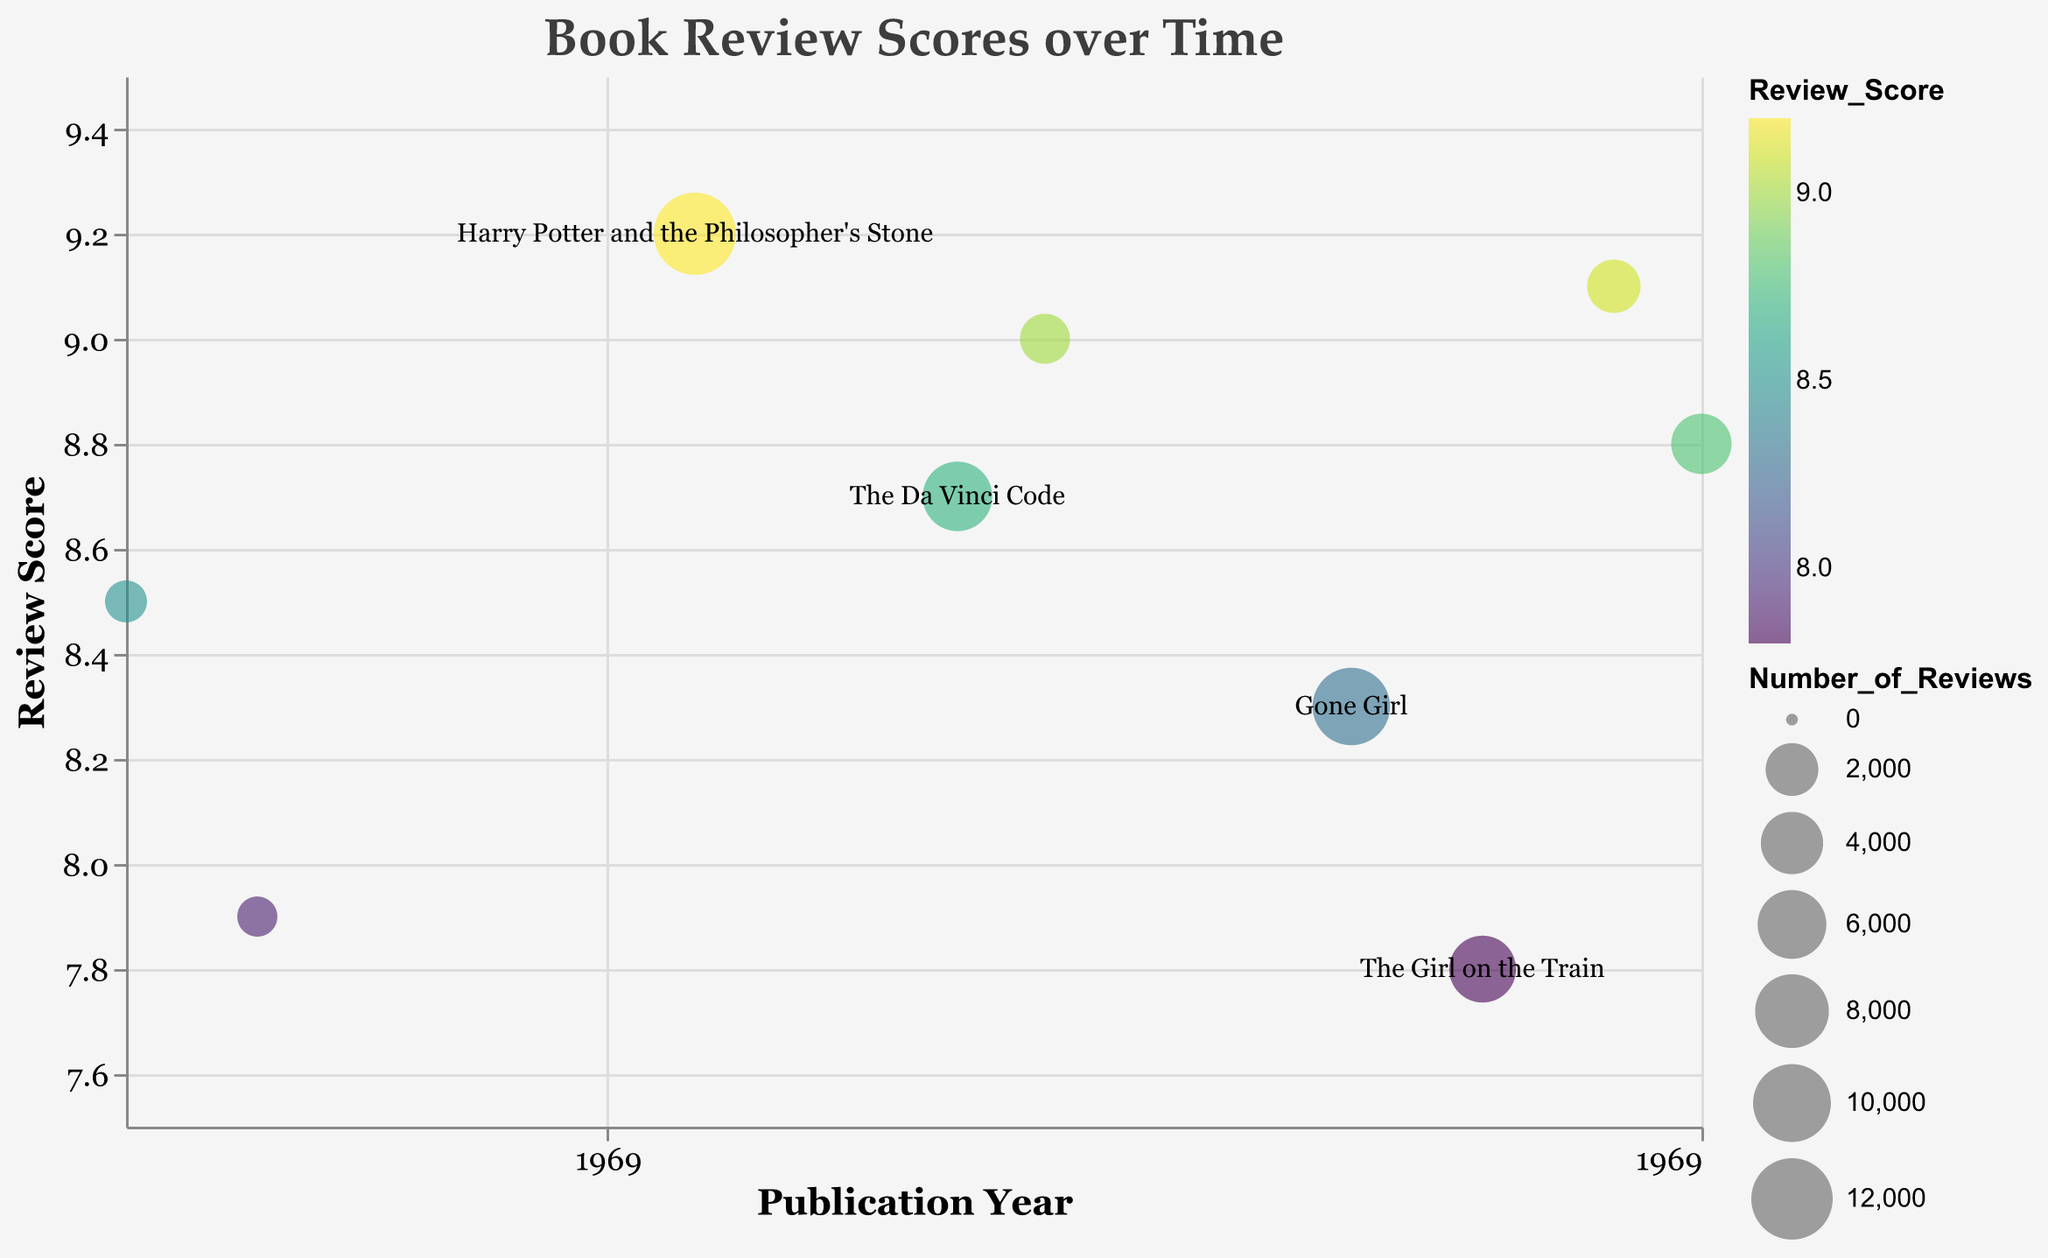How many books are represented in the chart? Count the number of distinct data points or bubbles in the chart.
Answer: 9 What is the title of the chart? Look at the text at the top center of the chart.
Answer: Book Review Scores over Time Which book has the highest review score and what is that score? Identify the highest point on the vertical axis and find the corresponding book title from the tooltip.
Answer: Harry Potter and the Philosopher's Stone, 9.2 What year was "The Book Thief" published and what is its review score? Refer to the tooltip information associated with "The Book Thief".
Answer: 2005, 9.0 Which book has the largest number of reviews? Look for the largest bubble on the chart and refer to the tooltip for the book title.
Answer: Harry Potter and the Philosopher's Stone Which book has the lowest review score and in which year was it published? Identify the lowest point on the vertical axis and find the corresponding book title and publication year from the tooltip.
Answer: The Girl on the Train, 2015 What is the average review score of all books published after 2000? Average the review scores of books published after 2000. These books are: "The Da Vinci Code" (8.7), "The Book Thief" (9.0), "Gone Girl" (8.3), "The Girl on the Train" (7.8), "Educated" (9.1), and "The Vanishing Half" (8.8). (8.7 + 9.0 + 8.3 + 7.8 + 9.1 + 8.8)/6
Answer: 8.62 Which book has the highest review score among those with more than 5000 reviews? Look for books with large bubbles (indicating more than 5000 reviews) and compare their review scores.
Answer: Harry Potter and the Philosopher's Stone, 9.2 Compare the review scores of "Gone Girl" and "The Vanishing Half". Which one has a higher score? Refer to the vertical position of the bubbles for "Gone Girl" and "The Vanishing Half" and compare their review scores.
Answer: The Vanishing Half How many books have been published in the last decade (2010-2020)? Count the number of bubbles for books with publication years between 2010 and 2020, inclusive.
Answer: 4 